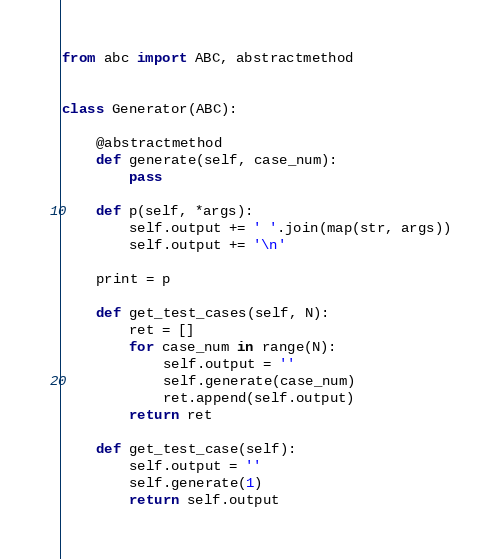<code> <loc_0><loc_0><loc_500><loc_500><_Python_>from abc import ABC, abstractmethod


class Generator(ABC):

    @abstractmethod
    def generate(self, case_num):
        pass

    def p(self, *args):
        self.output += ' '.join(map(str, args))
        self.output += '\n'

    print = p

    def get_test_cases(self, N):
        ret = []
        for case_num in range(N):
            self.output = ''
            self.generate(case_num)
            ret.append(self.output)
        return ret

    def get_test_case(self):
        self.output = ''
        self.generate(1)
        return self.output
</code> 